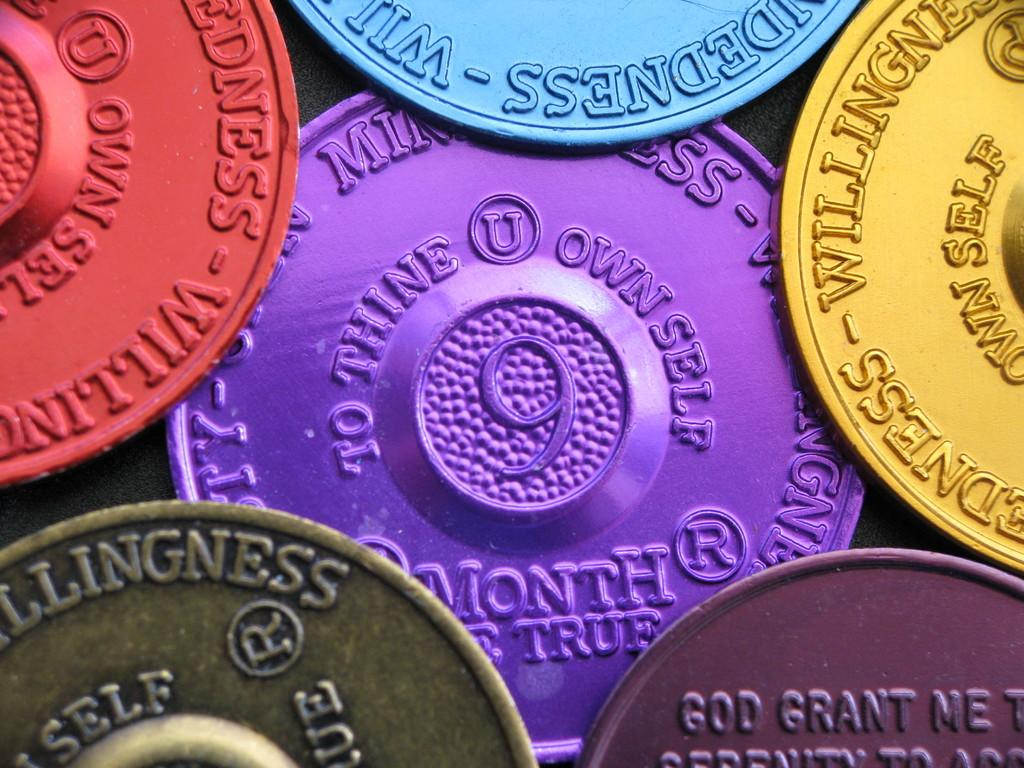Provide a one-sentence caption for the provided image. A purple coin surrounded by other colorful coins says "to thine own self" on it. 